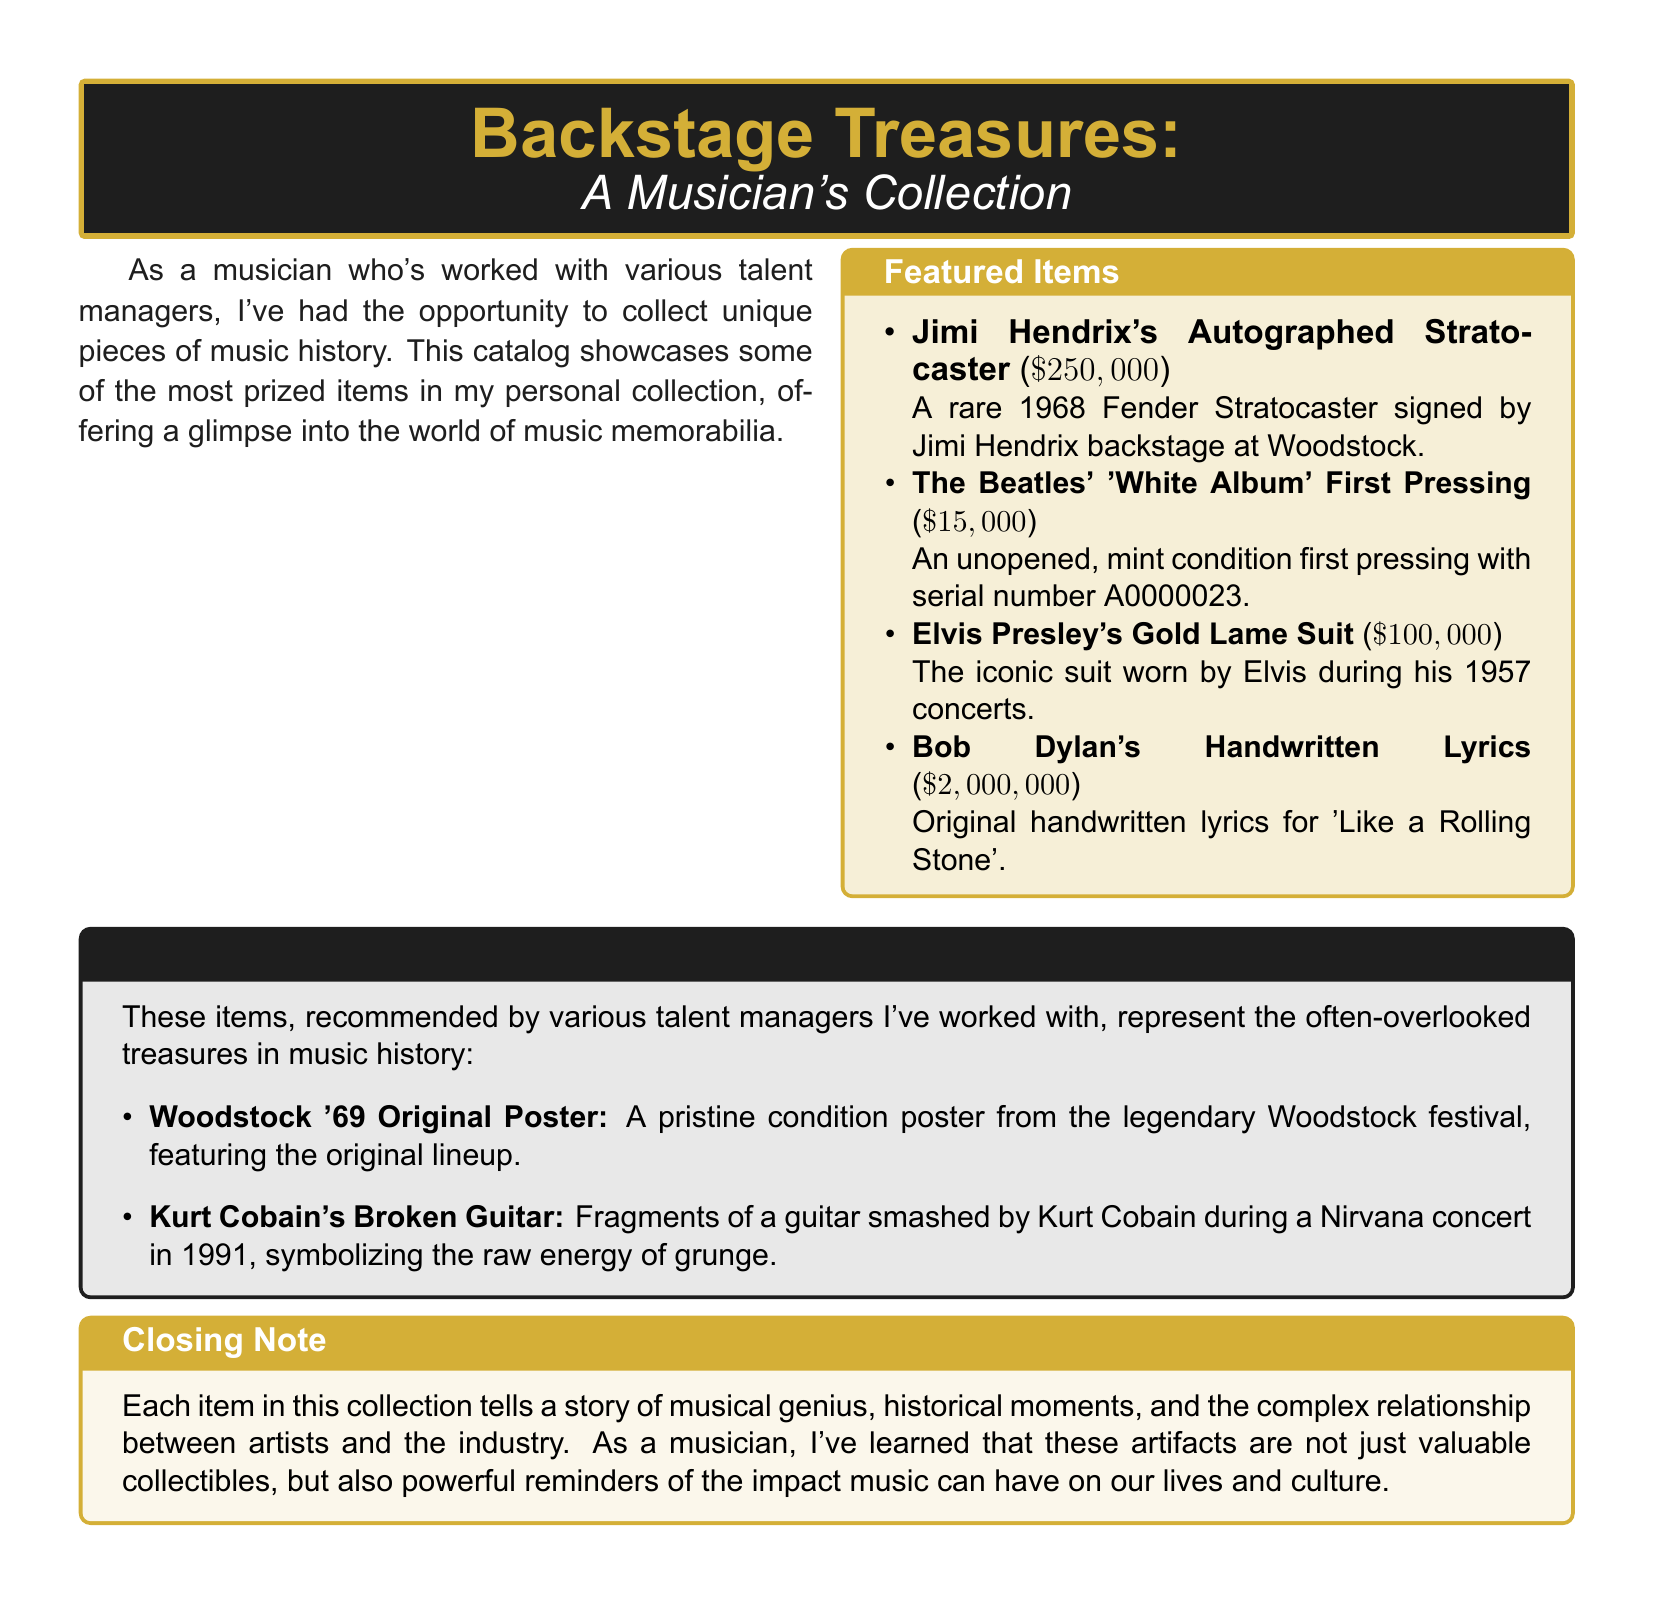What is the title of the catalog? The title is displayed prominently at the top of the document, introducing the collection of music memorabilia.
Answer: Backstage Treasures Who signed the rare Stratocaster? The information is located under the featured items, detailing the autograph of a famous musician on the instrument.
Answer: Jimi Hendrix How much is Bob Dylan's handwritten lyrics worth? The document lists the price next to the description of his handwritten lyrics for a specific song.
Answer: $2,000,000 What type of memorabilia is Elvis Presley's iconic item? The catalog specifies a unique clothing item associated with a renowned musician.
Answer: Gold Lame Suit What is the significance of Kurt Cobain's guitar fragments? The description highlights the cultural impact of the item, relating it to a specific concert and music genre.
Answer: Raw energy of grunge What is the serial number of The Beatles' White Album? The document mentions this detail in the description of the collectible.
Answer: A0000023 What is the closing note's main theme? The closing note summarizes the overarching message regarding the value of the items in relation to music and culture.
Answer: Impact of music What is included in the Manager's Pick section? The document explicitly lists the items that are considered hidden gems recommended by talent managers.
Answer: Hidden gems in music history 